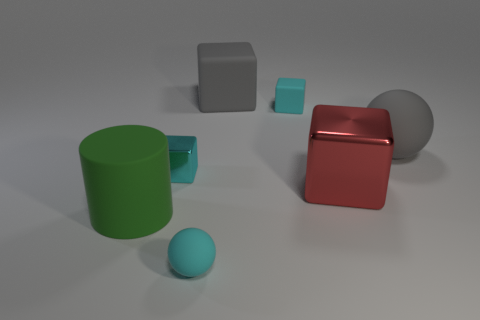There is another small block that is the same color as the tiny metallic cube; what is its material?
Provide a short and direct response. Rubber. What number of other objects are there of the same color as the small shiny cube?
Your answer should be very brief. 2. What number of cubes are either big gray matte objects or tiny cyan metallic things?
Your answer should be compact. 2. The rubber sphere on the left side of the large metal block that is to the right of the cyan sphere is what color?
Make the answer very short. Cyan. What is the shape of the large metal object?
Make the answer very short. Cube. There is a rubber ball that is to the left of the red block; is its size the same as the big shiny thing?
Offer a terse response. No. Are there any yellow balls that have the same material as the large gray ball?
Ensure brevity in your answer.  No. What number of things are either large matte objects that are in front of the big gray ball or large purple matte blocks?
Provide a succinct answer. 1. Are there any large purple blocks?
Your answer should be very brief. No. What is the shape of the big matte thing that is right of the small matte sphere and to the left of the large matte ball?
Your answer should be compact. Cube. 